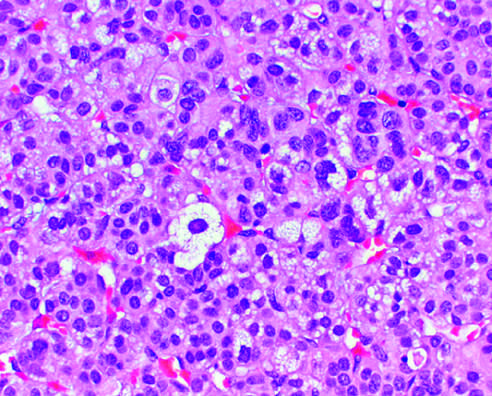re the neoplastic cells vacuolated because of the presence of intracytoplasmic lipid?
Answer the question using a single word or phrase. Yes 